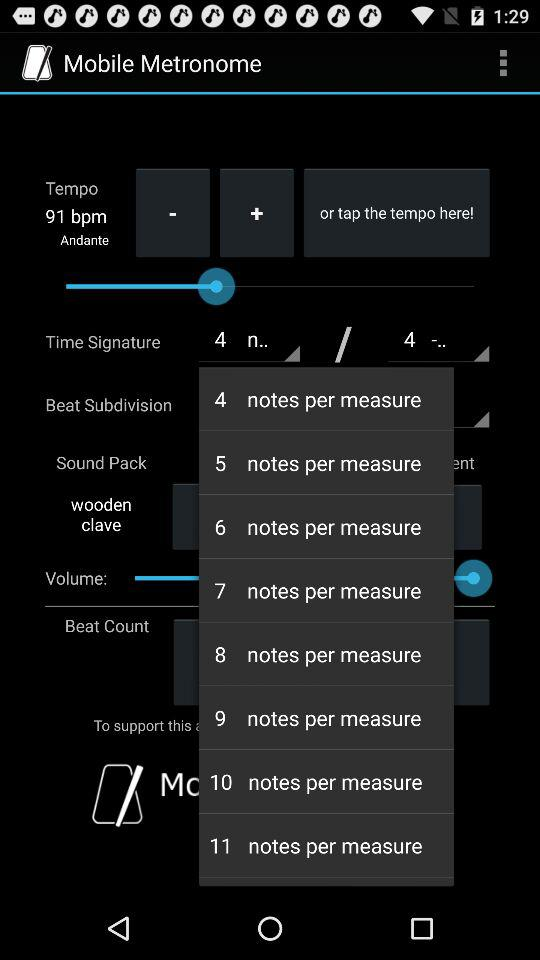What is the name of the application? The name of the application is "Mobile Metronome". 